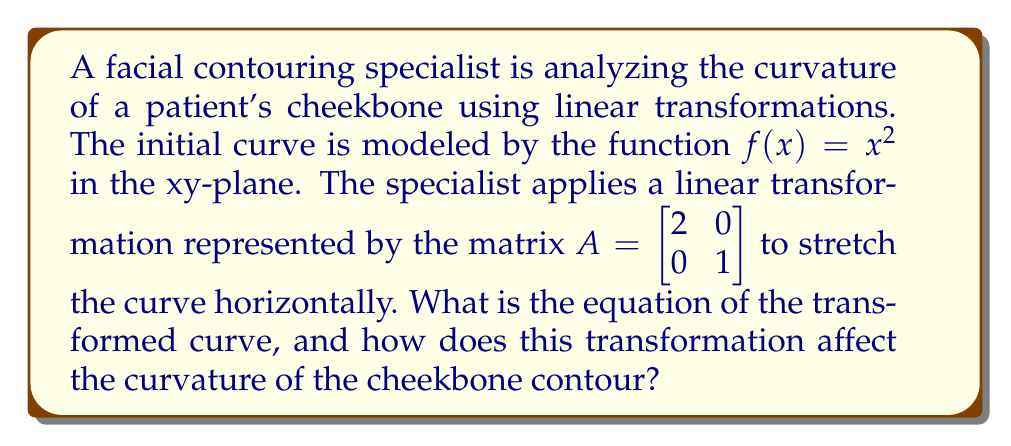Show me your answer to this math problem. 1) The initial curve is given by $f(x) = x^2$.

2) The linear transformation matrix $A = \begin{bmatrix} 2 & 0 \\ 0 & 1 \end{bmatrix}$ is applied to each point $(x, y)$ on the curve.

3) For a point $(x, y)$ on the original curve:
   $\begin{bmatrix} 2 & 0 \\ 0 & 1 \end{bmatrix} \begin{bmatrix} x \\ y \end{bmatrix} = \begin{bmatrix} 2x \\ y \end{bmatrix}$

4) This means that each x-coordinate is doubled, while y-coordinates remain unchanged.

5) To find the equation of the transformed curve, we need to express y in terms of the new x:
   $y = x^2$ (original equation)
   Let $x' = 2x$ (new x-coordinate after transformation)
   Then $x = \frac{x'}{2}$

6) Substituting into the original equation:
   $y = (\frac{x'}{2})^2 = \frac{(x')^2}{4}$

7) The new equation is therefore $y = \frac{x^2}{4}$ (dropping the prime for simplicity).

8) Effect on curvature: The transformation stretches the curve horizontally, making it appear flatter. This is because the y-values increase more slowly with respect to x compared to the original curve.

9) Mathematically, the curvature has decreased. The curvature of a function $y = f(x)$ is given by:
   $$\kappa = \frac{|f''(x)|}{(1 + (f'(x))^2)^{3/2}}$$
   
   For $f(x) = x^2$, $\kappa = \frac{2}{(1 + 4x^2)^{3/2}}$
   For the transformed curve $f(x) = \frac{x^2}{4}$, $\kappa = \frac{1/2}{(1 + x^2/4)^{3/2}}$

   The transformed curve has a smaller curvature for all x values.
Answer: $y = \frac{x^2}{4}$; decreased curvature 